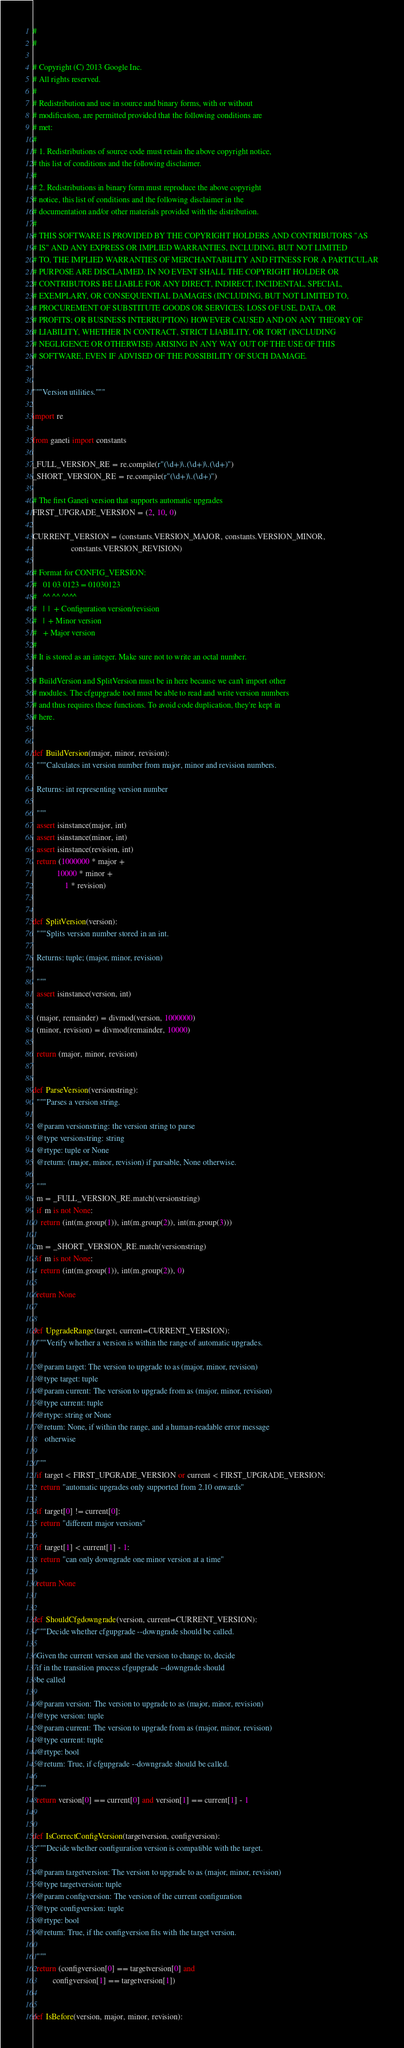<code> <loc_0><loc_0><loc_500><loc_500><_Python_>#
#

# Copyright (C) 2013 Google Inc.
# All rights reserved.
#
# Redistribution and use in source and binary forms, with or without
# modification, are permitted provided that the following conditions are
# met:
#
# 1. Redistributions of source code must retain the above copyright notice,
# this list of conditions and the following disclaimer.
#
# 2. Redistributions in binary form must reproduce the above copyright
# notice, this list of conditions and the following disclaimer in the
# documentation and/or other materials provided with the distribution.
#
# THIS SOFTWARE IS PROVIDED BY THE COPYRIGHT HOLDERS AND CONTRIBUTORS "AS
# IS" AND ANY EXPRESS OR IMPLIED WARRANTIES, INCLUDING, BUT NOT LIMITED
# TO, THE IMPLIED WARRANTIES OF MERCHANTABILITY AND FITNESS FOR A PARTICULAR
# PURPOSE ARE DISCLAIMED. IN NO EVENT SHALL THE COPYRIGHT HOLDER OR
# CONTRIBUTORS BE LIABLE FOR ANY DIRECT, INDIRECT, INCIDENTAL, SPECIAL,
# EXEMPLARY, OR CONSEQUENTIAL DAMAGES (INCLUDING, BUT NOT LIMITED TO,
# PROCUREMENT OF SUBSTITUTE GOODS OR SERVICES; LOSS OF USE, DATA, OR
# PROFITS; OR BUSINESS INTERRUPTION) HOWEVER CAUSED AND ON ANY THEORY OF
# LIABILITY, WHETHER IN CONTRACT, STRICT LIABILITY, OR TORT (INCLUDING
# NEGLIGENCE OR OTHERWISE) ARISING IN ANY WAY OUT OF THE USE OF THIS
# SOFTWARE, EVEN IF ADVISED OF THE POSSIBILITY OF SUCH DAMAGE.


"""Version utilities."""

import re

from ganeti import constants

_FULL_VERSION_RE = re.compile(r"(\d+)\.(\d+)\.(\d+)")
_SHORT_VERSION_RE = re.compile(r"(\d+)\.(\d+)")

# The first Ganeti version that supports automatic upgrades
FIRST_UPGRADE_VERSION = (2, 10, 0)

CURRENT_VERSION = (constants.VERSION_MAJOR, constants.VERSION_MINOR,
                   constants.VERSION_REVISION)

# Format for CONFIG_VERSION:
#   01 03 0123 = 01030123
#   ^^ ^^ ^^^^
#   |  |  + Configuration version/revision
#   |  + Minor version
#   + Major version
#
# It is stored as an integer. Make sure not to write an octal number.

# BuildVersion and SplitVersion must be in here because we can't import other
# modules. The cfgupgrade tool must be able to read and write version numbers
# and thus requires these functions. To avoid code duplication, they're kept in
# here.


def BuildVersion(major, minor, revision):
  """Calculates int version number from major, minor and revision numbers.

  Returns: int representing version number

  """
  assert isinstance(major, int)
  assert isinstance(minor, int)
  assert isinstance(revision, int)
  return (1000000 * major +
            10000 * minor +
                1 * revision)


def SplitVersion(version):
  """Splits version number stored in an int.

  Returns: tuple; (major, minor, revision)

  """
  assert isinstance(version, int)

  (major, remainder) = divmod(version, 1000000)
  (minor, revision) = divmod(remainder, 10000)

  return (major, minor, revision)


def ParseVersion(versionstring):
  """Parses a version string.

  @param versionstring: the version string to parse
  @type versionstring: string
  @rtype: tuple or None
  @return: (major, minor, revision) if parsable, None otherwise.

  """
  m = _FULL_VERSION_RE.match(versionstring)
  if m is not None:
    return (int(m.group(1)), int(m.group(2)), int(m.group(3)))

  m = _SHORT_VERSION_RE.match(versionstring)
  if m is not None:
    return (int(m.group(1)), int(m.group(2)), 0)

  return None


def UpgradeRange(target, current=CURRENT_VERSION):
  """Verify whether a version is within the range of automatic upgrades.

  @param target: The version to upgrade to as (major, minor, revision)
  @type target: tuple
  @param current: The version to upgrade from as (major, minor, revision)
  @type current: tuple
  @rtype: string or None
  @return: None, if within the range, and a human-readable error message
      otherwise

  """
  if target < FIRST_UPGRADE_VERSION or current < FIRST_UPGRADE_VERSION:
    return "automatic upgrades only supported from 2.10 onwards"

  if target[0] != current[0]:
    return "different major versions"

  if target[1] < current[1] - 1:
    return "can only downgrade one minor version at a time"

  return None


def ShouldCfgdowngrade(version, current=CURRENT_VERSION):
  """Decide whether cfgupgrade --downgrade should be called.

  Given the current version and the version to change to, decide
  if in the transition process cfgupgrade --downgrade should
  be called

  @param version: The version to upgrade to as (major, minor, revision)
  @type version: tuple
  @param current: The version to upgrade from as (major, minor, revision)
  @type current: tuple
  @rtype: bool
  @return: True, if cfgupgrade --downgrade should be called.

  """
  return version[0] == current[0] and version[1] == current[1] - 1


def IsCorrectConfigVersion(targetversion, configversion):
  """Decide whether configuration version is compatible with the target.

  @param targetversion: The version to upgrade to as (major, minor, revision)
  @type targetversion: tuple
  @param configversion: The version of the current configuration
  @type configversion: tuple
  @rtype: bool
  @return: True, if the configversion fits with the target version.

  """
  return (configversion[0] == targetversion[0] and
          configversion[1] == targetversion[1])


def IsBefore(version, major, minor, revision):</code> 